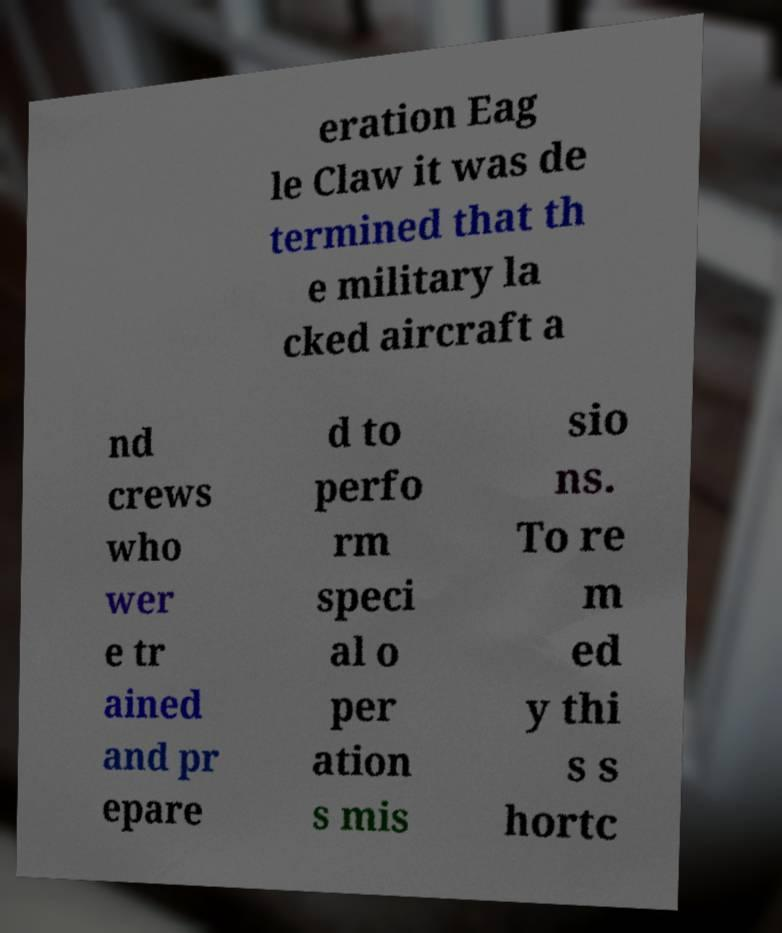Can you read and provide the text displayed in the image?This photo seems to have some interesting text. Can you extract and type it out for me? eration Eag le Claw it was de termined that th e military la cked aircraft a nd crews who wer e tr ained and pr epare d to perfo rm speci al o per ation s mis sio ns. To re m ed y thi s s hortc 